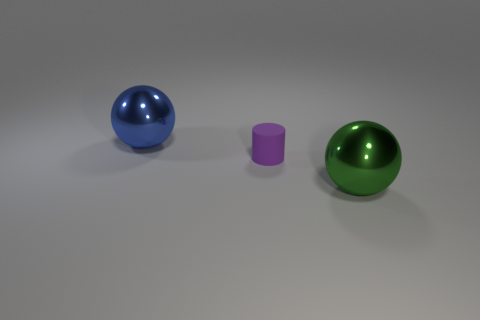Is there any other thing that has the same color as the matte cylinder?
Make the answer very short. No. Are there more rubber things that are in front of the green ball than blue spheres that are to the right of the big blue thing?
Your answer should be very brief. No. What number of balls are the same size as the purple object?
Give a very brief answer. 0. Is the number of small purple objects that are on the right side of the tiny purple rubber object less than the number of purple rubber things left of the large blue ball?
Give a very brief answer. No. Are there any green objects of the same shape as the small purple matte object?
Offer a very short reply. No. Is the shape of the large blue object the same as the green thing?
Offer a very short reply. Yes. What number of tiny objects are shiny balls or cyan objects?
Provide a short and direct response. 0. Are there more green balls than tiny metal cylinders?
Ensure brevity in your answer.  Yes. There is a thing that is made of the same material as the blue ball; what size is it?
Give a very brief answer. Large. Do the metal thing on the left side of the large green ball and the object in front of the tiny cylinder have the same size?
Give a very brief answer. Yes. 